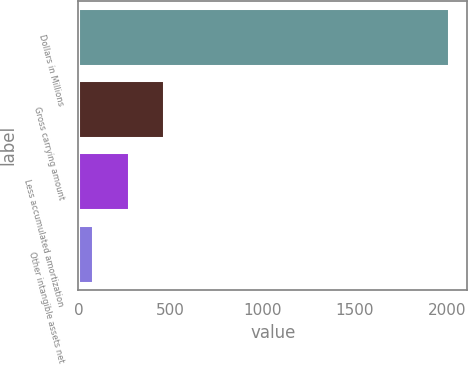<chart> <loc_0><loc_0><loc_500><loc_500><bar_chart><fcel>Dollars in Millions<fcel>Gross carrying amount<fcel>Less accumulated amortization<fcel>Other intangible assets net<nl><fcel>2007<fcel>465.4<fcel>272.7<fcel>80<nl></chart> 